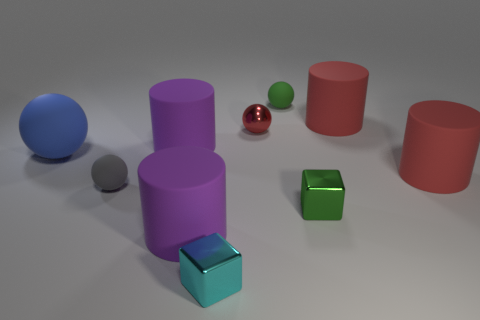What number of big things are either purple matte cylinders or blue metallic cylinders?
Give a very brief answer. 2. How big is the blue rubber thing?
Make the answer very short. Large. There is a blue ball; does it have the same size as the block that is behind the cyan metal cube?
Your answer should be very brief. No. How many blue objects are small metal cubes or small rubber objects?
Offer a terse response. 0. How many gray balls are there?
Your response must be concise. 1. What size is the metallic cube that is on the left side of the small green metal thing?
Give a very brief answer. Small. Do the blue object and the green matte ball have the same size?
Give a very brief answer. No. What number of things are big blue spheres or cylinders right of the tiny red metallic object?
Your answer should be compact. 3. What material is the large ball?
Provide a short and direct response. Rubber. Are there any other things of the same color as the large matte ball?
Offer a very short reply. No. 